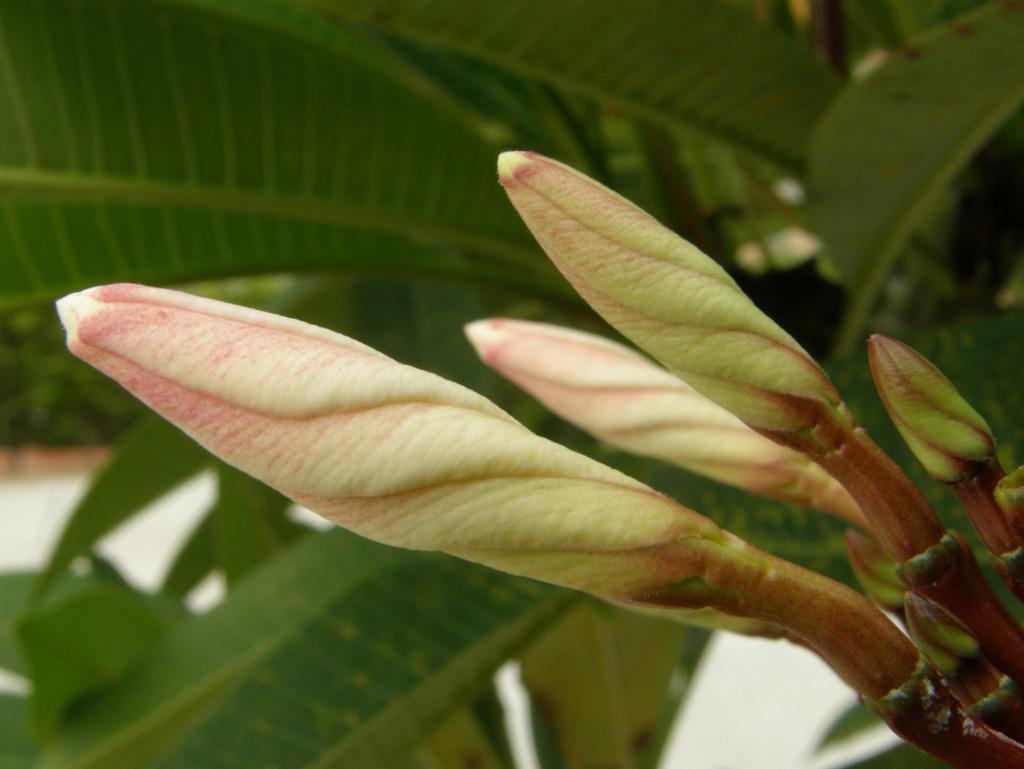What is present in the picture? There is a plant in the picture. What stage of growth are the flowers on the plant in? The plant has flower buds. What part of the plant can be seen in the picture? There are leaves visible in the picture. What type of punishment is being administered to the plant in the picture? There is no punishment being administered to the plant in the picture; it is simply a plant with flower buds and leaves. 